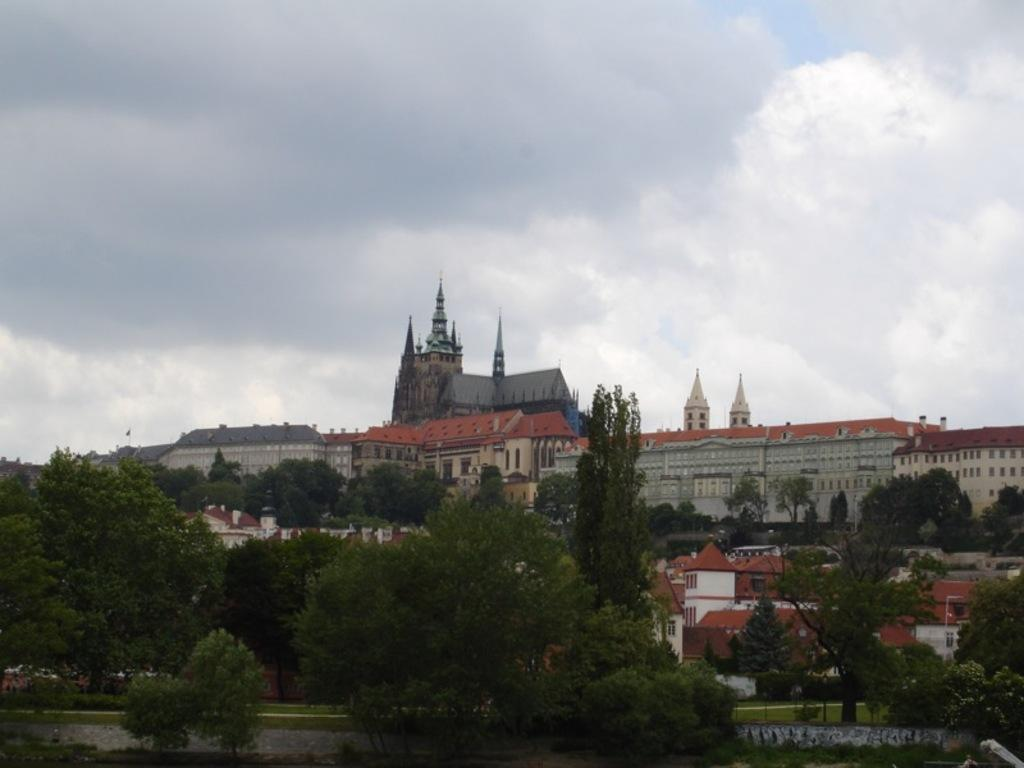What structures are located in the middle of the image? There are buildings in the middle of the image. What type of vegetation can be seen in the image? There are trees and grass in the image. What is visible in the background of the image? The sky is visible in the image. What can be observed in the sky? There are clouds in the sky. What is the father's reaction to the regretful situation in the image? There is no father or regretful situation present in the image. What type of emotion can be seen on the father's face in the image? There is no father present in the image, so it is not possible to determine any emotions or reactions. 